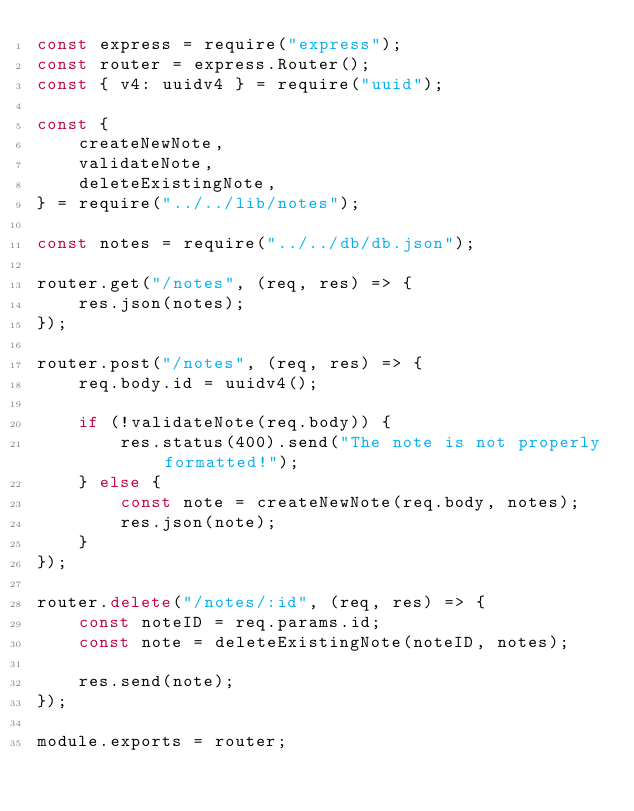Convert code to text. <code><loc_0><loc_0><loc_500><loc_500><_JavaScript_>const express = require("express");
const router = express.Router();
const { v4: uuidv4 } = require("uuid");

const {
    createNewNote,
    validateNote,
    deleteExistingNote,
} = require("../../lib/notes");

const notes = require("../../db/db.json");

router.get("/notes", (req, res) => {
    res.json(notes);
});

router.post("/notes", (req, res) => {
    req.body.id = uuidv4();

    if (!validateNote(req.body)) {
        res.status(400).send("The note is not properly formatted!");
    } else {
        const note = createNewNote(req.body, notes);
        res.json(note);
    }
});

router.delete("/notes/:id", (req, res) => {
    const noteID = req.params.id;
    const note = deleteExistingNote(noteID, notes);

    res.send(note);
});

module.exports = router;
</code> 